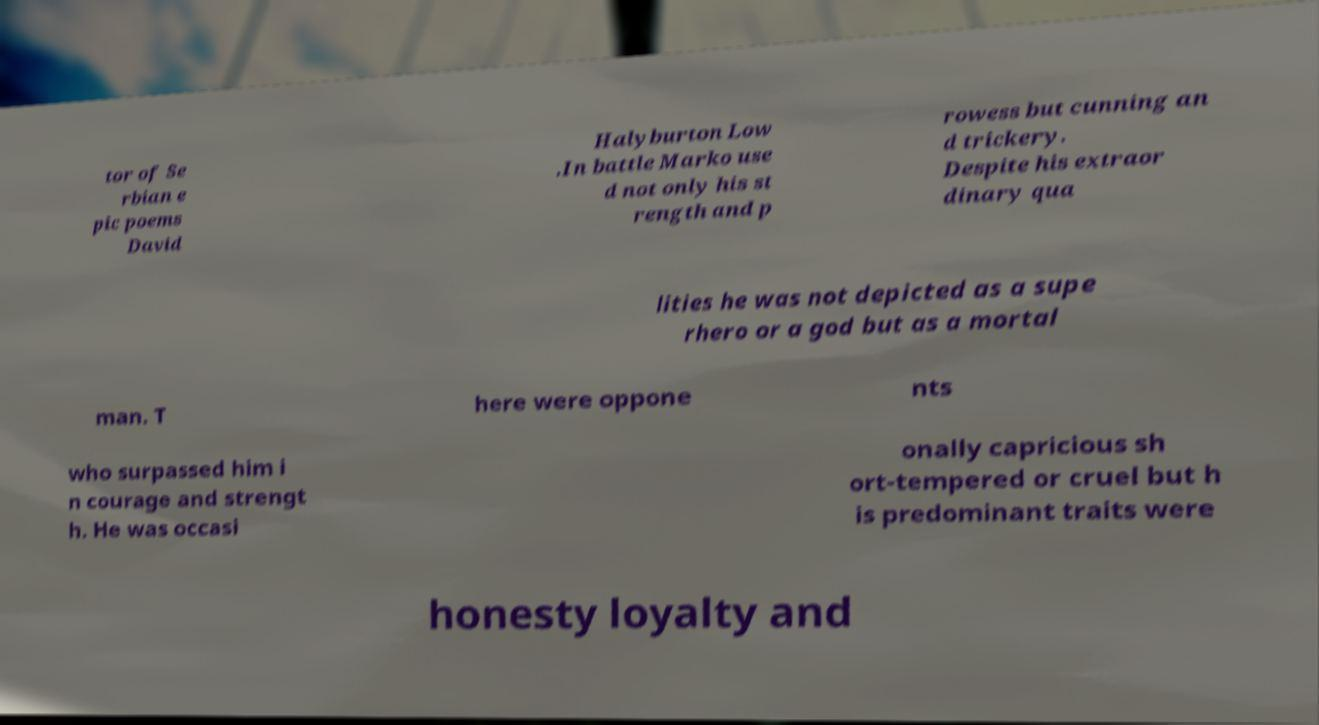Can you accurately transcribe the text from the provided image for me? tor of Se rbian e pic poems David Halyburton Low .In battle Marko use d not only his st rength and p rowess but cunning an d trickery. Despite his extraor dinary qua lities he was not depicted as a supe rhero or a god but as a mortal man. T here were oppone nts who surpassed him i n courage and strengt h. He was occasi onally capricious sh ort-tempered or cruel but h is predominant traits were honesty loyalty and 